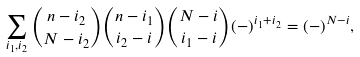<formula> <loc_0><loc_0><loc_500><loc_500>\sum _ { i _ { 1 } , i _ { 2 } } { n - i _ { 2 } \choose N - i _ { 2 } } { n - i _ { 1 } \choose i _ { 2 } - i } { N - i \choose i _ { 1 } - i } ( - ) ^ { i _ { 1 } + i _ { 2 } } = ( - ) ^ { N - i } ,</formula> 